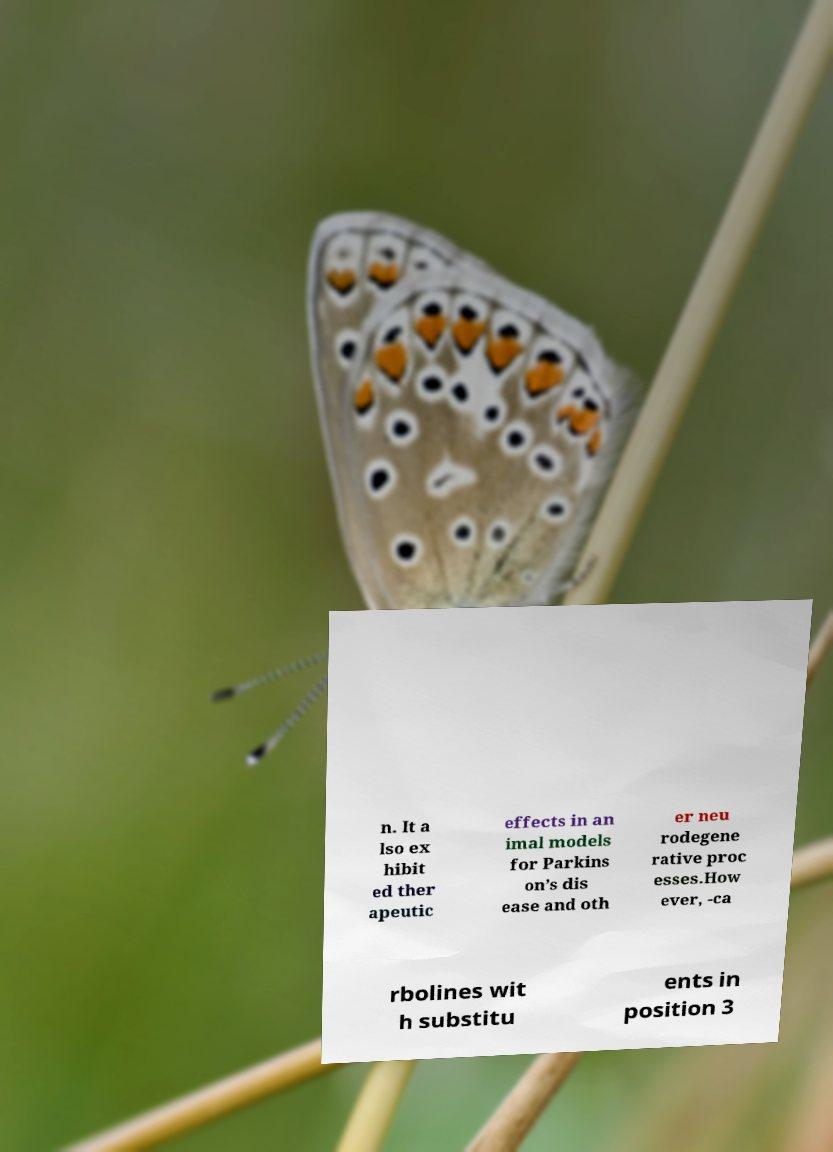For documentation purposes, I need the text within this image transcribed. Could you provide that? n. It a lso ex hibit ed ther apeutic effects in an imal models for Parkins on’s dis ease and oth er neu rodegene rative proc esses.How ever, -ca rbolines wit h substitu ents in position 3 